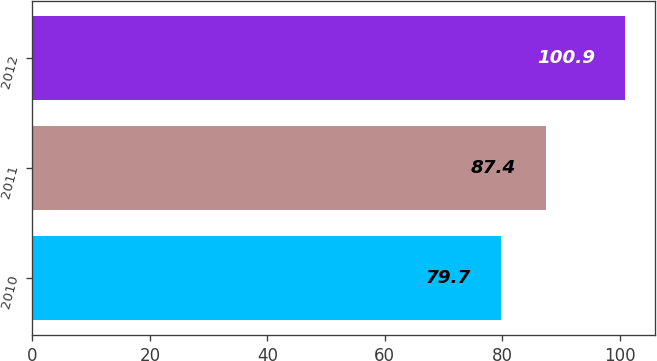Convert chart to OTSL. <chart><loc_0><loc_0><loc_500><loc_500><bar_chart><fcel>2010<fcel>2011<fcel>2012<nl><fcel>79.7<fcel>87.4<fcel>100.9<nl></chart> 